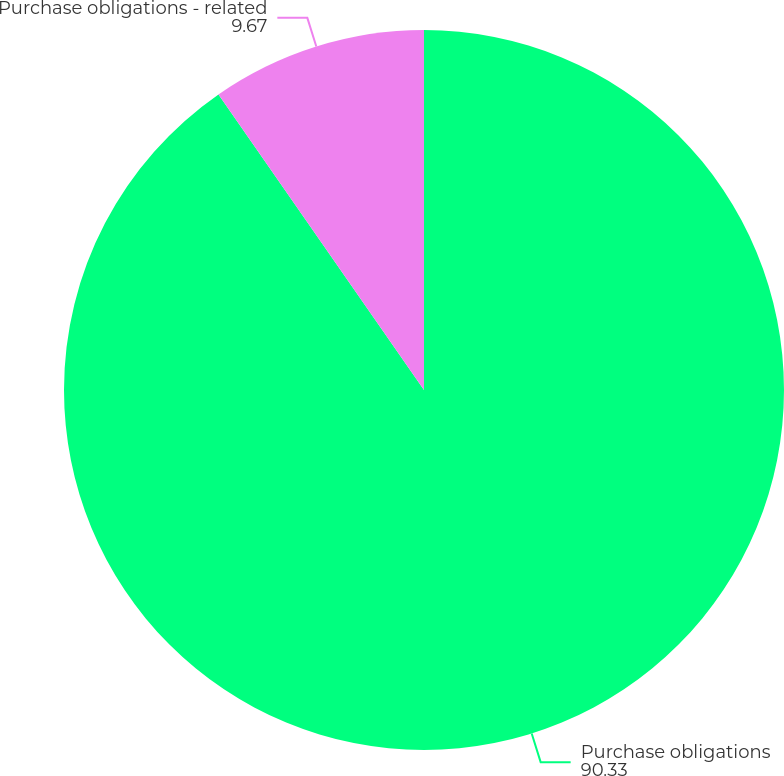Convert chart. <chart><loc_0><loc_0><loc_500><loc_500><pie_chart><fcel>Purchase obligations<fcel>Purchase obligations - related<nl><fcel>90.33%<fcel>9.67%<nl></chart> 